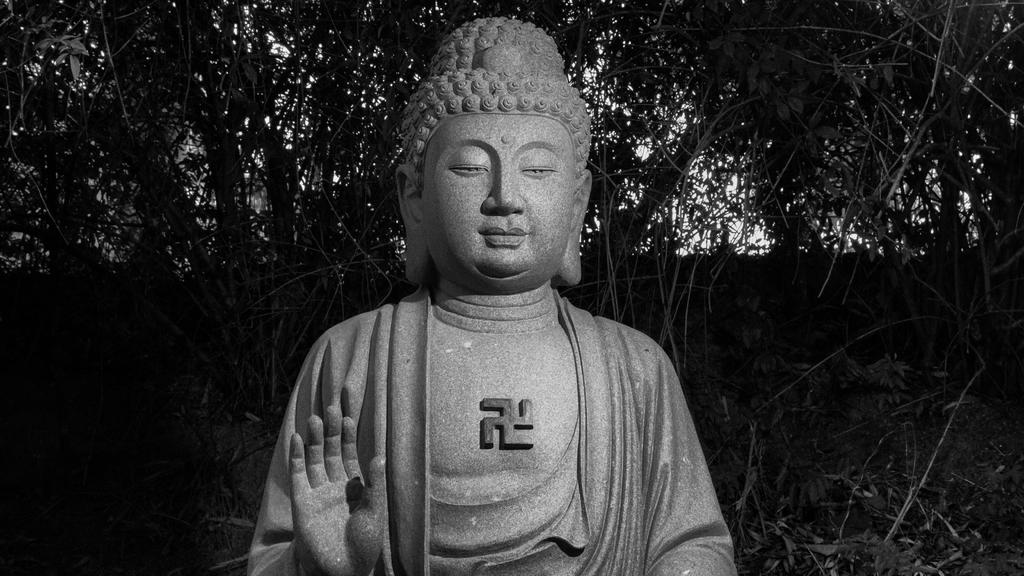What is the color scheme of the image? The image is black and white. What is the main subject in the image? There is a sculpture in the image. What can be seen in the background of the image? There are trees in the background of the image. What type of toys can be seen in the image? There are no toys present in the image; it features a sculpture and trees in the background. What is the governor's role in the image? There is no governor present in the image, as it only contains a sculpture and trees in the background. 